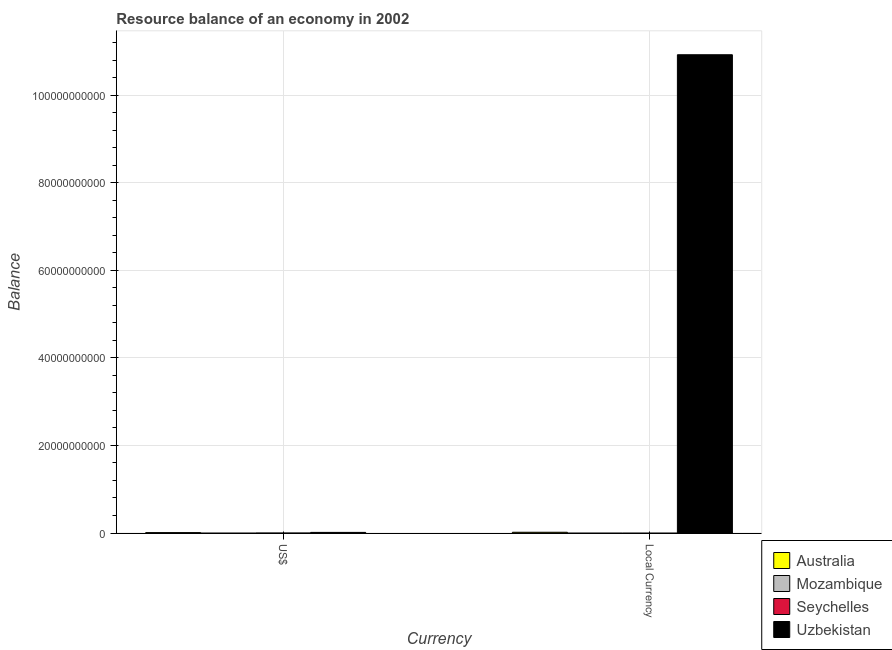Are the number of bars on each tick of the X-axis equal?
Your answer should be compact. Yes. What is the label of the 1st group of bars from the left?
Provide a succinct answer. US$. Across all countries, what is the maximum resource balance in us$?
Offer a very short reply. 1.42e+08. Across all countries, what is the minimum resource balance in constant us$?
Provide a succinct answer. 0. In which country was the resource balance in us$ maximum?
Your response must be concise. Uzbekistan. What is the total resource balance in constant us$ in the graph?
Offer a terse response. 1.09e+11. What is the difference between the resource balance in constant us$ in Australia and that in Uzbekistan?
Provide a succinct answer. -1.09e+11. What is the difference between the resource balance in constant us$ in Seychelles and the resource balance in us$ in Mozambique?
Provide a short and direct response. 0. What is the average resource balance in us$ per country?
Your response must be concise. 5.84e+07. What is the difference between the resource balance in us$ and resource balance in constant us$ in Uzbekistan?
Offer a terse response. -1.09e+11. What is the ratio of the resource balance in us$ in Australia to that in Uzbekistan?
Your answer should be compact. 0.64. Are the values on the major ticks of Y-axis written in scientific E-notation?
Provide a succinct answer. No. Where does the legend appear in the graph?
Your response must be concise. Bottom right. How are the legend labels stacked?
Your answer should be very brief. Vertical. What is the title of the graph?
Offer a terse response. Resource balance of an economy in 2002. What is the label or title of the X-axis?
Your answer should be very brief. Currency. What is the label or title of the Y-axis?
Your answer should be compact. Balance. What is the Balance in Australia in US$?
Keep it short and to the point. 9.16e+07. What is the Balance of Mozambique in US$?
Provide a succinct answer. 0. What is the Balance of Uzbekistan in US$?
Ensure brevity in your answer.  1.42e+08. What is the Balance in Australia in Local Currency?
Ensure brevity in your answer.  1.75e+08. What is the Balance in Mozambique in Local Currency?
Ensure brevity in your answer.  0. What is the Balance in Seychelles in Local Currency?
Ensure brevity in your answer.  0. What is the Balance in Uzbekistan in Local Currency?
Ensure brevity in your answer.  1.09e+11. Across all Currency, what is the maximum Balance in Australia?
Keep it short and to the point. 1.75e+08. Across all Currency, what is the maximum Balance in Uzbekistan?
Make the answer very short. 1.09e+11. Across all Currency, what is the minimum Balance of Australia?
Offer a very short reply. 9.16e+07. Across all Currency, what is the minimum Balance in Uzbekistan?
Offer a very short reply. 1.42e+08. What is the total Balance in Australia in the graph?
Provide a succinct answer. 2.67e+08. What is the total Balance of Uzbekistan in the graph?
Your answer should be very brief. 1.09e+11. What is the difference between the Balance in Australia in US$ and that in Local Currency?
Provide a short and direct response. -8.34e+07. What is the difference between the Balance in Uzbekistan in US$ and that in Local Currency?
Your response must be concise. -1.09e+11. What is the difference between the Balance of Australia in US$ and the Balance of Uzbekistan in Local Currency?
Your response must be concise. -1.09e+11. What is the average Balance in Australia per Currency?
Make the answer very short. 1.33e+08. What is the average Balance in Mozambique per Currency?
Your answer should be very brief. 0. What is the average Balance in Uzbekistan per Currency?
Make the answer very short. 5.47e+1. What is the difference between the Balance of Australia and Balance of Uzbekistan in US$?
Make the answer very short. -5.04e+07. What is the difference between the Balance in Australia and Balance in Uzbekistan in Local Currency?
Your answer should be very brief. -1.09e+11. What is the ratio of the Balance in Australia in US$ to that in Local Currency?
Offer a terse response. 0.52. What is the ratio of the Balance of Uzbekistan in US$ to that in Local Currency?
Keep it short and to the point. 0. What is the difference between the highest and the second highest Balance in Australia?
Your answer should be compact. 8.34e+07. What is the difference between the highest and the second highest Balance in Uzbekistan?
Offer a terse response. 1.09e+11. What is the difference between the highest and the lowest Balance of Australia?
Your response must be concise. 8.34e+07. What is the difference between the highest and the lowest Balance in Uzbekistan?
Make the answer very short. 1.09e+11. 